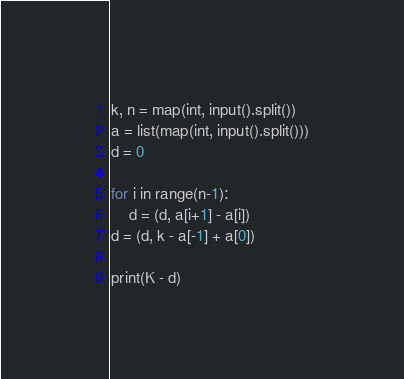<code> <loc_0><loc_0><loc_500><loc_500><_Python_>k, n = map(int, input().split())
a = list(map(int, input().split()))
d = 0

for i in range(n-1):
    d = (d, a[i+1] - a[i])
d = (d, k - a[-1] + a[0])

print(K - d)</code> 